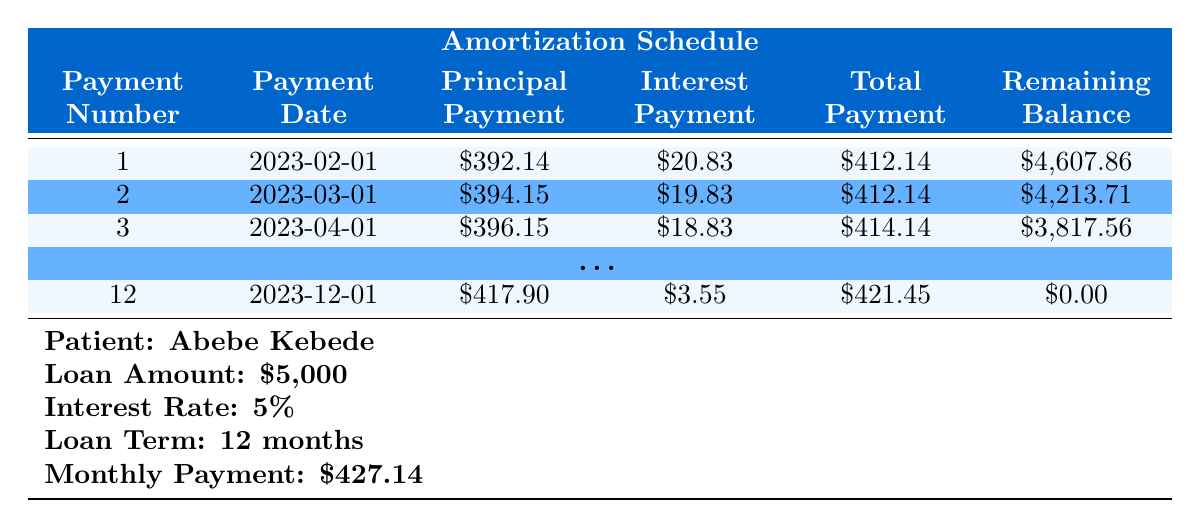What is the total loan amount for Fatima Mensah? The table indicates the loan amount listed under Fatima Mensah which is directly mentioned as 3000.
Answer: 3000 How much is the monthly payment for Abebe Kebede? The monthly payment for Abebe Kebede is given directly in the table as 427.14.
Answer: 427.14 Did Abebe Kebede complete his loan repayment in 12 months? The final payment date listed in the table for Abebe Kebede is 2023-12-01 and he has a total of 12 payments, confirming he completed the repayment within the loan term.
Answer: Yes What was the principal payment amount in the second payment for Fatima Mensah? In the payment schedule for Fatima Mensah, the principal payment amount for the second payment is shown as 502.77.
Answer: 502.77 Calculate the total interest payments made by Fatima Mensah over her loan term. To find the total interest payments for Fatima Mensah, sum the interest payments across all payments: 20.66 + 17.34 + 13.99 + 4.23 = 56.22.
Answer: 56.22 How many total payments did Abebe Kebede make until the loan was fully paid off? The table indicates that Abebe Kebede made a total of 12 payments before the loan was fully paid off, as seen in the payment schedule.
Answer: 12 What is the remaining balance after the fifth payment for Fatima Mensah? The payment schedule does not list a fifth payment for Fatima Mensah, but it lists the remaining balance after the total of four payments where the last balance shown is 0.00. Hence, the fifth payment does not exist.
Answer: Not applicable Which patient paid a higher amount in total payments, Abebe Kebede or Fatima Mensah? Calculate total payments: Abebe paid 12 * 427.14 = 5,126.68 and Fatima paid 6 * 520.11 = 3,120.66. Clearly, Abebe Kebede has a higher total payment.
Answer: Abebe Kebede What was the interest payment on the final payment for Abebe Kebede? According to the payment schedule, the interest payment amount on the last payment (12th) for Abebe Kebede is shown as 3.55.
Answer: 3.55 